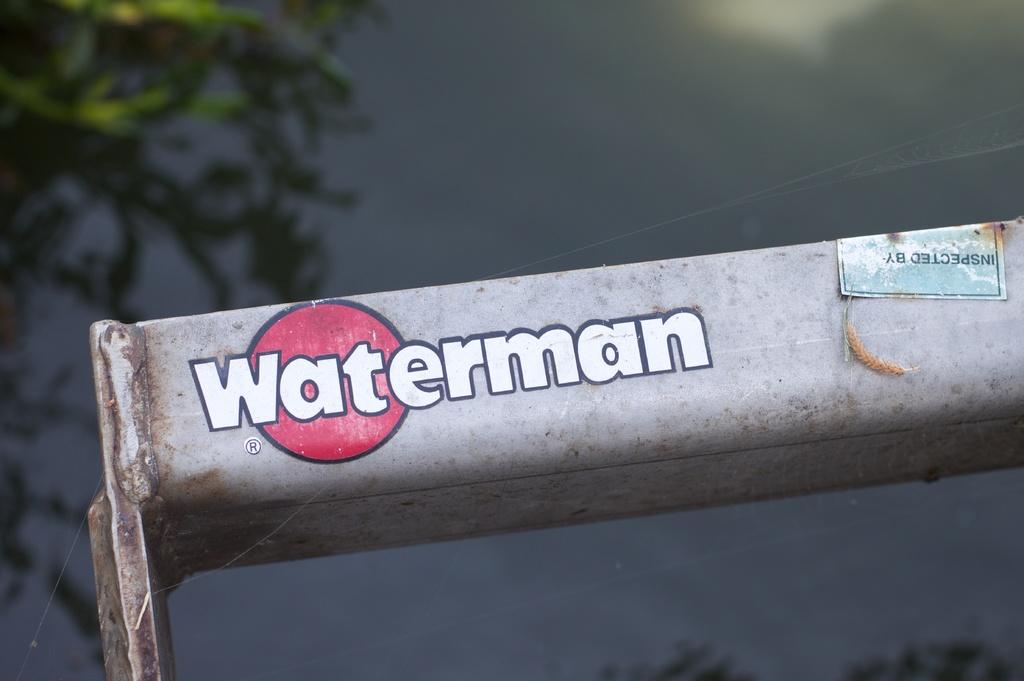What is the main object in the image? There is a white color metal object in the image. What is written on the metal object? The words "WATER MAN" are printed on the metal object. What can be seen in the background of the image? There is a green color tree in the background of the image. Can you hear the horn of the dad's car in the image? There is no mention of a car or a horn in the image, so it cannot be heard. 